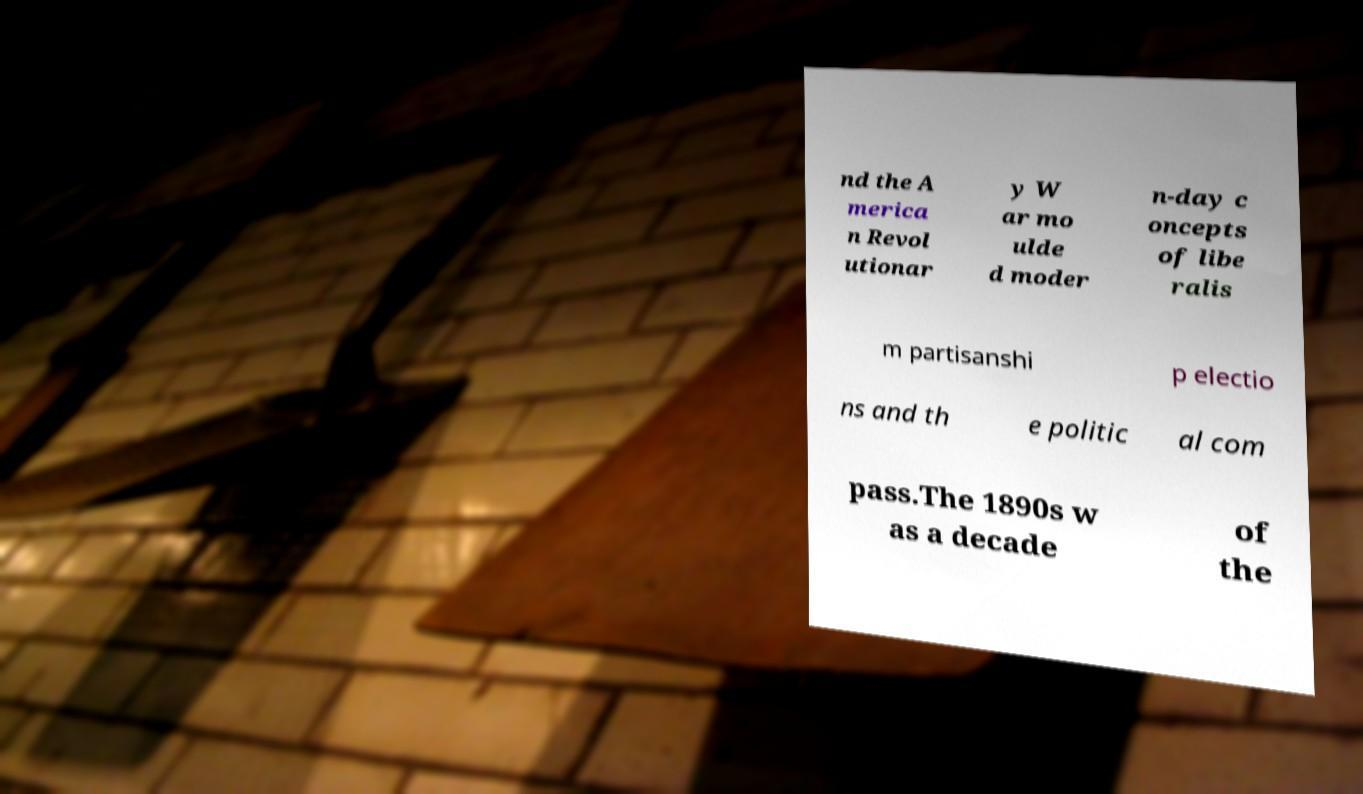Please identify and transcribe the text found in this image. nd the A merica n Revol utionar y W ar mo ulde d moder n-day c oncepts of libe ralis m partisanshi p electio ns and th e politic al com pass.The 1890s w as a decade of the 